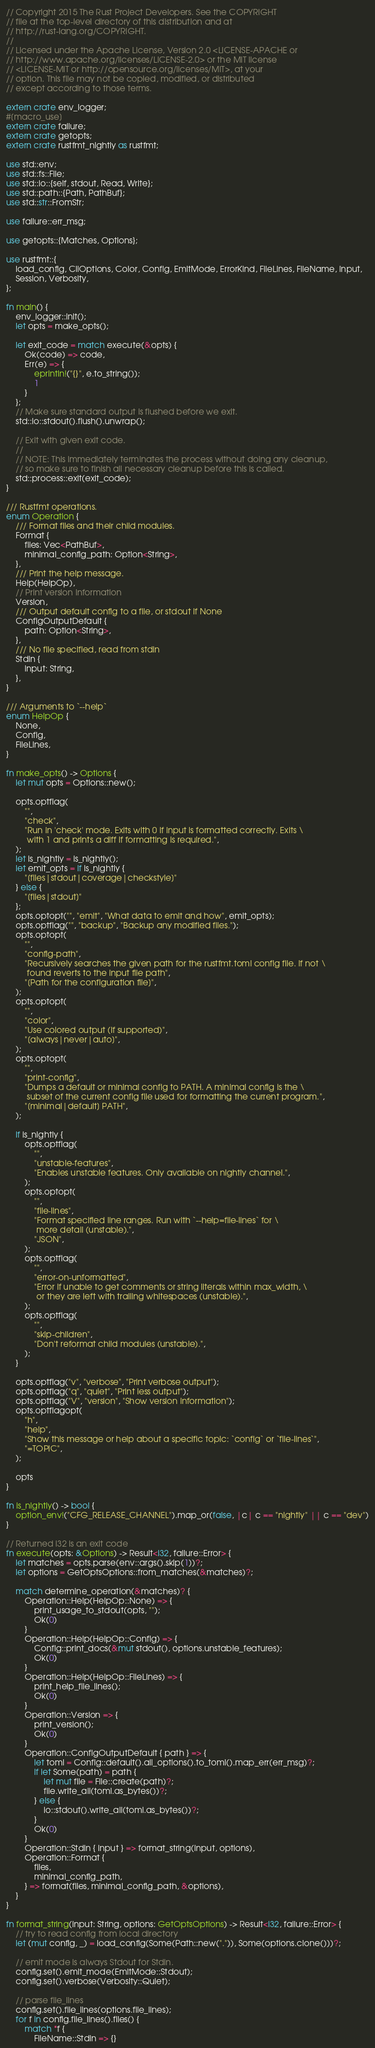<code> <loc_0><loc_0><loc_500><loc_500><_Rust_>// Copyright 2015 The Rust Project Developers. See the COPYRIGHT
// file at the top-level directory of this distribution and at
// http://rust-lang.org/COPYRIGHT.
//
// Licensed under the Apache License, Version 2.0 <LICENSE-APACHE or
// http://www.apache.org/licenses/LICENSE-2.0> or the MIT license
// <LICENSE-MIT or http://opensource.org/licenses/MIT>, at your
// option. This file may not be copied, modified, or distributed
// except according to those terms.

extern crate env_logger;
#[macro_use]
extern crate failure;
extern crate getopts;
extern crate rustfmt_nightly as rustfmt;

use std::env;
use std::fs::File;
use std::io::{self, stdout, Read, Write};
use std::path::{Path, PathBuf};
use std::str::FromStr;

use failure::err_msg;

use getopts::{Matches, Options};

use rustfmt::{
    load_config, CliOptions, Color, Config, EmitMode, ErrorKind, FileLines, FileName, Input,
    Session, Verbosity,
};

fn main() {
    env_logger::init();
    let opts = make_opts();

    let exit_code = match execute(&opts) {
        Ok(code) => code,
        Err(e) => {
            eprintln!("{}", e.to_string());
            1
        }
    };
    // Make sure standard output is flushed before we exit.
    std::io::stdout().flush().unwrap();

    // Exit with given exit code.
    //
    // NOTE: This immediately terminates the process without doing any cleanup,
    // so make sure to finish all necessary cleanup before this is called.
    std::process::exit(exit_code);
}

/// Rustfmt operations.
enum Operation {
    /// Format files and their child modules.
    Format {
        files: Vec<PathBuf>,
        minimal_config_path: Option<String>,
    },
    /// Print the help message.
    Help(HelpOp),
    // Print version information
    Version,
    /// Output default config to a file, or stdout if None
    ConfigOutputDefault {
        path: Option<String>,
    },
    /// No file specified, read from stdin
    Stdin {
        input: String,
    },
}

/// Arguments to `--help`
enum HelpOp {
    None,
    Config,
    FileLines,
}

fn make_opts() -> Options {
    let mut opts = Options::new();

    opts.optflag(
        "",
        "check",
        "Run in 'check' mode. Exits with 0 if input is formatted correctly. Exits \
         with 1 and prints a diff if formatting is required.",
    );
    let is_nightly = is_nightly();
    let emit_opts = if is_nightly {
        "[files|stdout|coverage|checkstyle]"
    } else {
        "[files|stdout]"
    };
    opts.optopt("", "emit", "What data to emit and how", emit_opts);
    opts.optflag("", "backup", "Backup any modified files.");
    opts.optopt(
        "",
        "config-path",
        "Recursively searches the given path for the rustfmt.toml config file. If not \
         found reverts to the input file path",
        "[Path for the configuration file]",
    );
    opts.optopt(
        "",
        "color",
        "Use colored output (if supported)",
        "[always|never|auto]",
    );
    opts.optopt(
        "",
        "print-config",
        "Dumps a default or minimal config to PATH. A minimal config is the \
         subset of the current config file used for formatting the current program.",
        "[minimal|default] PATH",
    );

    if is_nightly {
        opts.optflag(
            "",
            "unstable-features",
            "Enables unstable features. Only available on nightly channel.",
        );
        opts.optopt(
            "",
            "file-lines",
            "Format specified line ranges. Run with `--help=file-lines` for \
             more detail (unstable).",
            "JSON",
        );
        opts.optflag(
            "",
            "error-on-unformatted",
            "Error if unable to get comments or string literals within max_width, \
             or they are left with trailing whitespaces (unstable).",
        );
        opts.optflag(
            "",
            "skip-children",
            "Don't reformat child modules (unstable).",
        );
    }

    opts.optflag("v", "verbose", "Print verbose output");
    opts.optflag("q", "quiet", "Print less output");
    opts.optflag("V", "version", "Show version information");
    opts.optflagopt(
        "h",
        "help",
        "Show this message or help about a specific topic: `config` or `file-lines`",
        "=TOPIC",
    );

    opts
}

fn is_nightly() -> bool {
    option_env!("CFG_RELEASE_CHANNEL").map_or(false, |c| c == "nightly" || c == "dev")
}

// Returned i32 is an exit code
fn execute(opts: &Options) -> Result<i32, failure::Error> {
    let matches = opts.parse(env::args().skip(1))?;
    let options = GetOptsOptions::from_matches(&matches)?;

    match determine_operation(&matches)? {
        Operation::Help(HelpOp::None) => {
            print_usage_to_stdout(opts, "");
            Ok(0)
        }
        Operation::Help(HelpOp::Config) => {
            Config::print_docs(&mut stdout(), options.unstable_features);
            Ok(0)
        }
        Operation::Help(HelpOp::FileLines) => {
            print_help_file_lines();
            Ok(0)
        }
        Operation::Version => {
            print_version();
            Ok(0)
        }
        Operation::ConfigOutputDefault { path } => {
            let toml = Config::default().all_options().to_toml().map_err(err_msg)?;
            if let Some(path) = path {
                let mut file = File::create(path)?;
                file.write_all(toml.as_bytes())?;
            } else {
                io::stdout().write_all(toml.as_bytes())?;
            }
            Ok(0)
        }
        Operation::Stdin { input } => format_string(input, options),
        Operation::Format {
            files,
            minimal_config_path,
        } => format(files, minimal_config_path, &options),
    }
}

fn format_string(input: String, options: GetOptsOptions) -> Result<i32, failure::Error> {
    // try to read config from local directory
    let (mut config, _) = load_config(Some(Path::new(".")), Some(options.clone()))?;

    // emit mode is always Stdout for Stdin.
    config.set().emit_mode(EmitMode::Stdout);
    config.set().verbose(Verbosity::Quiet);

    // parse file_lines
    config.set().file_lines(options.file_lines);
    for f in config.file_lines().files() {
        match *f {
            FileName::Stdin => {}</code> 